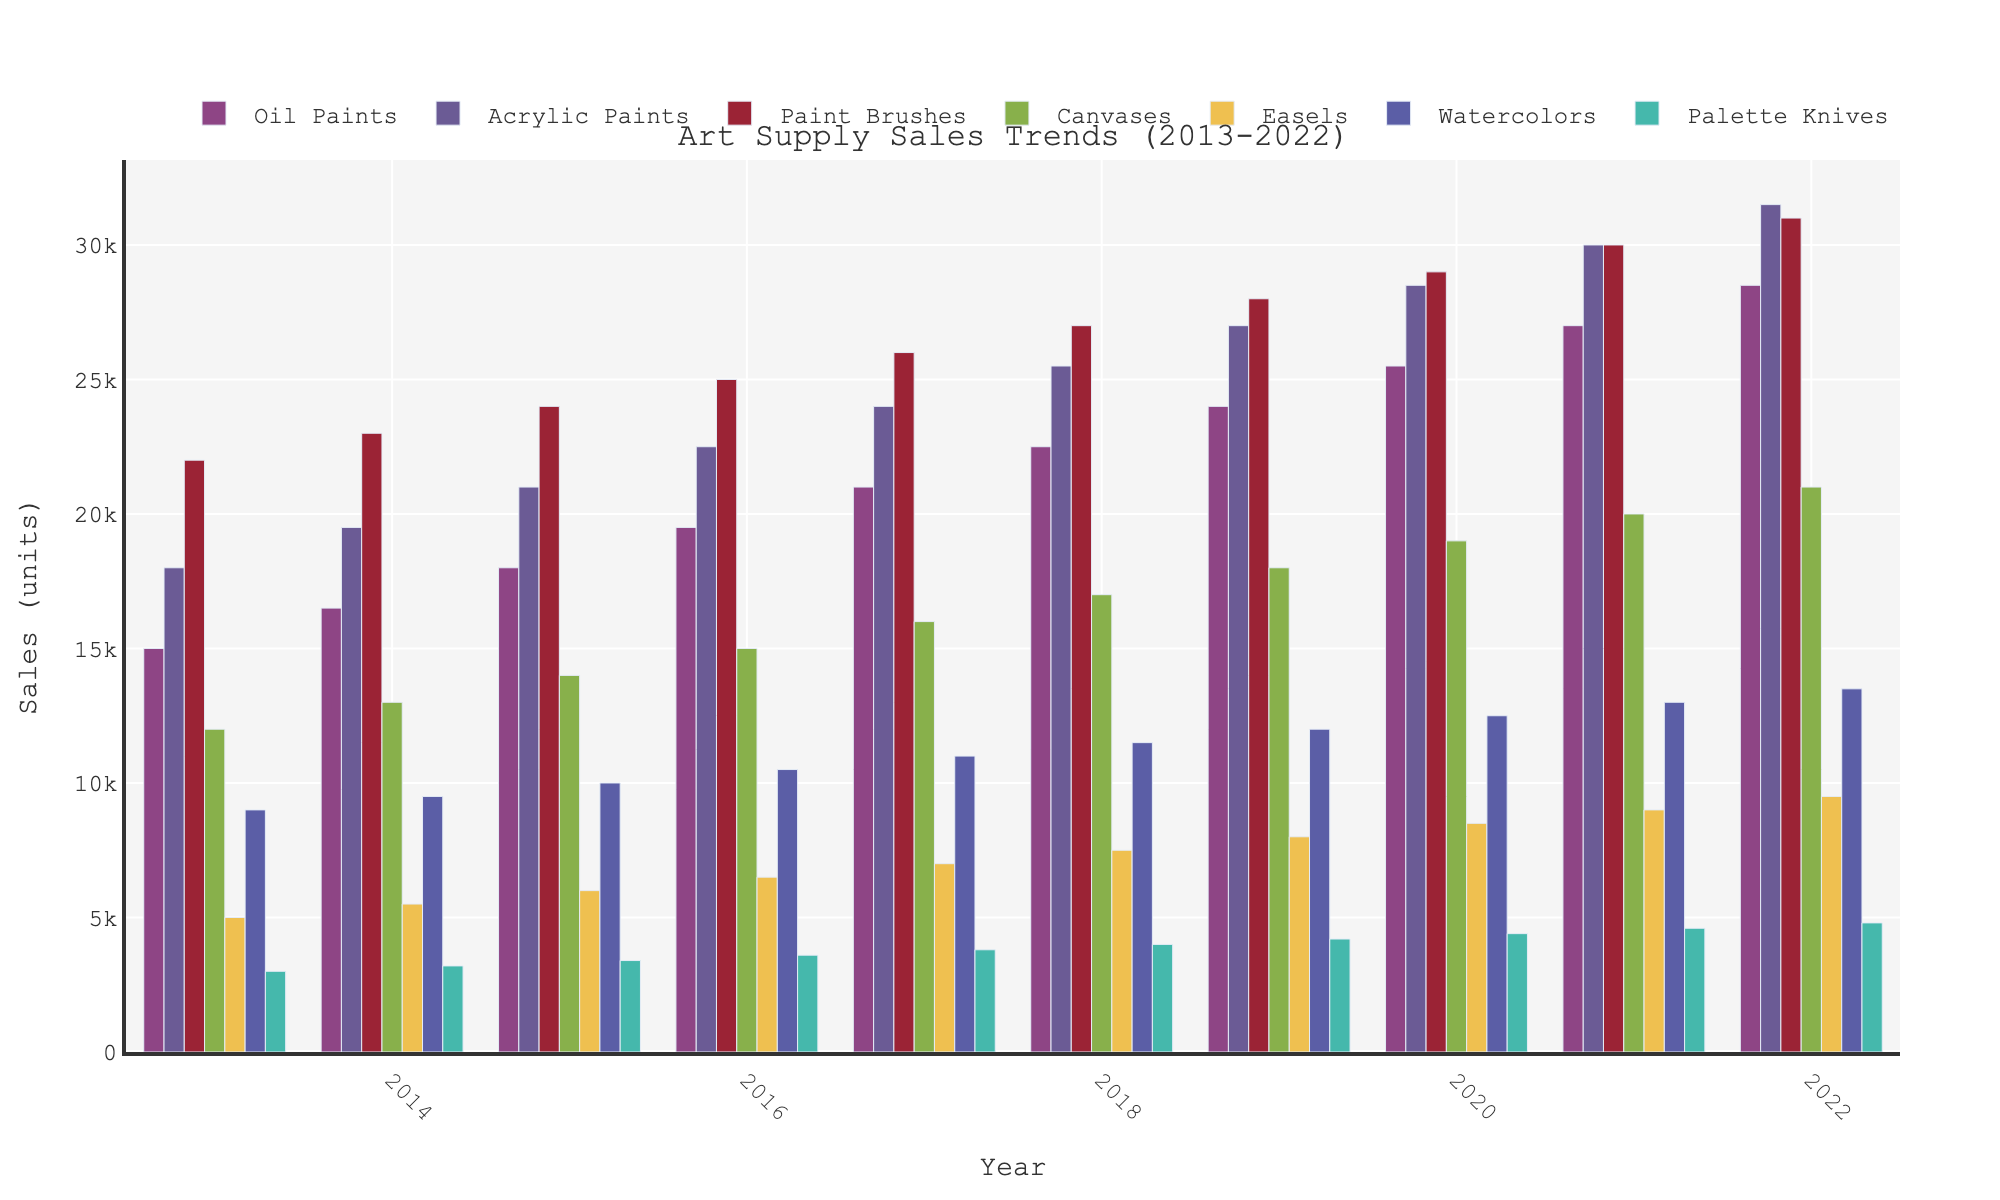What is the sales trend for Oil Paints from 2013 to 2022? Looking at the bar heights for Oil Paints from left to right, we see that they increase each year consistently from 15,000 in 2013 to 28,500 in 2022.
Answer: Consistently increasing Which product category had the highest sales in 2020? Observing the bar heights in the year 2020, the Paint Brushes category has the tallest bar, indicating it had the highest sales in that year.
Answer: Paint Brushes Between Acrylic Paints and Watercolors, which category had a faster growth from 2013 to 2022? Calculate the sales difference for both categories over the years. Acrylic Paints grew from 18,000 to 31,500, a difference of 13,500. Watercolors grew from 9,000 to 13,500, a difference of 4,500. Acrylic Paints had the faster growth.
Answer: Acrylic Paints In which year did Canvases sales surpass 15,000 units for the first time? Checking the heights of the Canvases bars through the years, we see that they first surpass 15,000 units in 2016.
Answer: 2016 What is the combined sales of Easels and Palette Knives in 2017? Add the sales of Easels (7,000) and Palette Knives (3,800) in 2017. The combined sales equal 10,800 units.
Answer: 10,800 units Which product had the least sales in 2022? Looking at the bar heights in 2022, Palette Knives is the shortest bar, indicating it had the least sales in that year.
Answer: Palette Knives What is the overall sales trend for Paint Brushes over the 10 years? Observing the bar heights for Paint Brushes from 2013 to 2022, we can see a clear upward trend each year.
Answer: Increasing In 2019, how did the sales of Canvases compare to those of Easels? Look at the bar heights for Canvases (18,000) and Easels (8,000) in 2019. Canvases had higher sales.
Answer: Canvases had higher sales What was the difference in sales between Oil Paints and Acrylic Paints in 2015? Subtract the sales of Oil Paints (18,000) from Acrylic Paints (21,000). The difference is 3,000 units.
Answer: 3,000 units Which year had the most uniform sales distribution across all product categories? By inspecting the bars in the chart, 2022 shows the most uniform heights without any category significantly deviating, indicating more uniform sales distribution.
Answer: 2022 